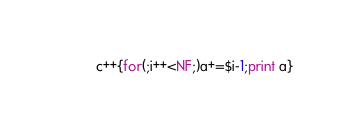<code> <loc_0><loc_0><loc_500><loc_500><_Awk_>c++{for(;i++<NF;)a+=$i-1;print a}</code> 